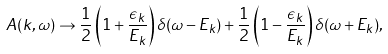<formula> <loc_0><loc_0><loc_500><loc_500>A ( { k } , \omega ) \to \frac { 1 } { 2 } \left ( 1 + \frac { \epsilon _ { k } } { E _ { k } } \right ) \delta ( \omega - E _ { k } ) + \frac { 1 } { 2 } \left ( 1 - \frac { \epsilon _ { k } } { E _ { k } } \right ) \delta ( \omega + E _ { k } ) ,</formula> 